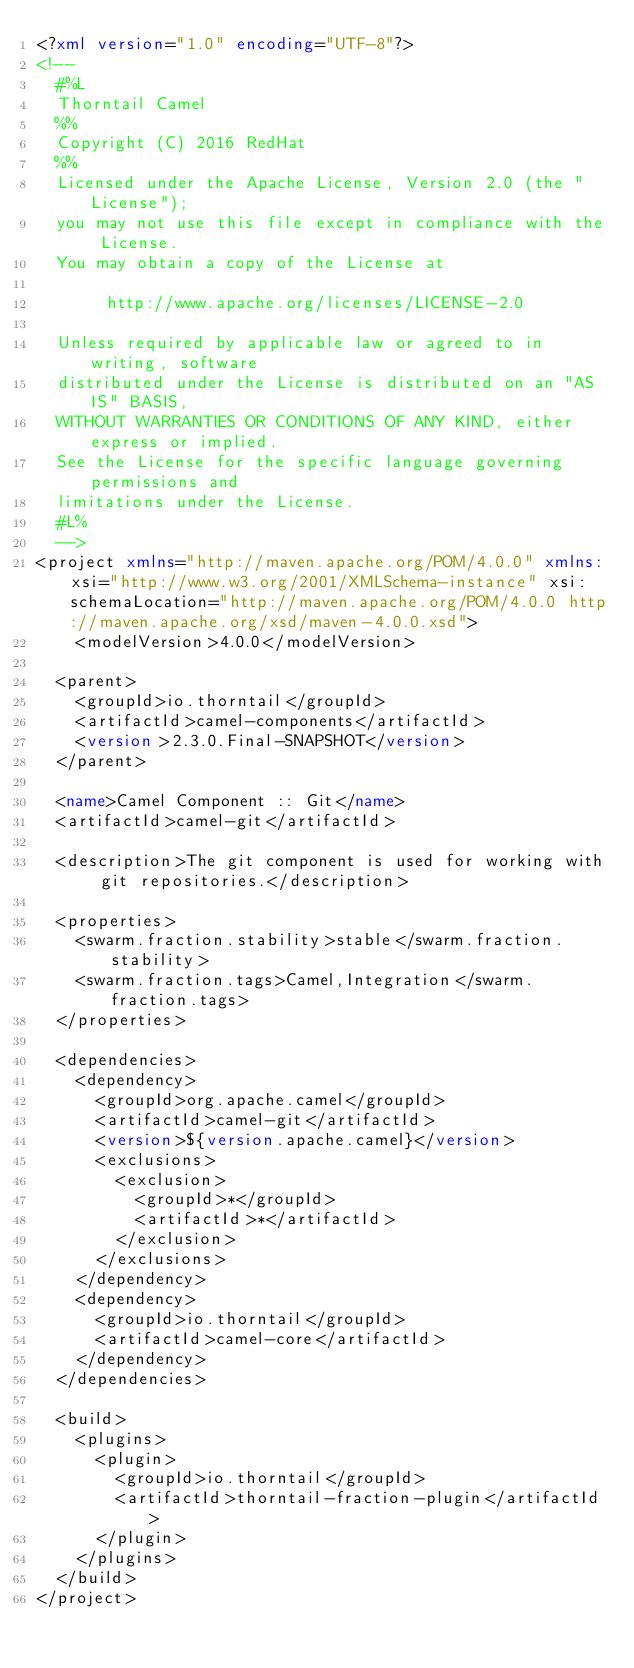<code> <loc_0><loc_0><loc_500><loc_500><_XML_><?xml version="1.0" encoding="UTF-8"?>
<!--
  #%L
  Thorntail Camel
  %%
  Copyright (C) 2016 RedHat
  %%
  Licensed under the Apache License, Version 2.0 (the "License");
  you may not use this file except in compliance with the License.
  You may obtain a copy of the License at
  
       http://www.apache.org/licenses/LICENSE-2.0
  
  Unless required by applicable law or agreed to in writing, software
  distributed under the License is distributed on an "AS IS" BASIS,
  WITHOUT WARRANTIES OR CONDITIONS OF ANY KIND, either express or implied.
  See the License for the specific language governing permissions and
  limitations under the License.
  #L%
  -->
<project xmlns="http://maven.apache.org/POM/4.0.0" xmlns:xsi="http://www.w3.org/2001/XMLSchema-instance" xsi:schemaLocation="http://maven.apache.org/POM/4.0.0 http://maven.apache.org/xsd/maven-4.0.0.xsd">
    <modelVersion>4.0.0</modelVersion>

  <parent>
    <groupId>io.thorntail</groupId>
    <artifactId>camel-components</artifactId>
    <version>2.3.0.Final-SNAPSHOT</version>
  </parent>

  <name>Camel Component :: Git</name>
  <artifactId>camel-git</artifactId>

  <description>The git component is used for working with git repositories.</description>
  
  <properties>
    <swarm.fraction.stability>stable</swarm.fraction.stability>
    <swarm.fraction.tags>Camel,Integration</swarm.fraction.tags>
  </properties>

  <dependencies>
    <dependency>
      <groupId>org.apache.camel</groupId>
      <artifactId>camel-git</artifactId>
      <version>${version.apache.camel}</version>
      <exclusions>
        <exclusion>
          <groupId>*</groupId>
          <artifactId>*</artifactId>
        </exclusion>
      </exclusions>
    </dependency>
    <dependency>
      <groupId>io.thorntail</groupId>
      <artifactId>camel-core</artifactId>
    </dependency>
  </dependencies>

  <build>
    <plugins>
      <plugin>
        <groupId>io.thorntail</groupId>
        <artifactId>thorntail-fraction-plugin</artifactId>
      </plugin>
    </plugins>
  </build>
</project>
</code> 